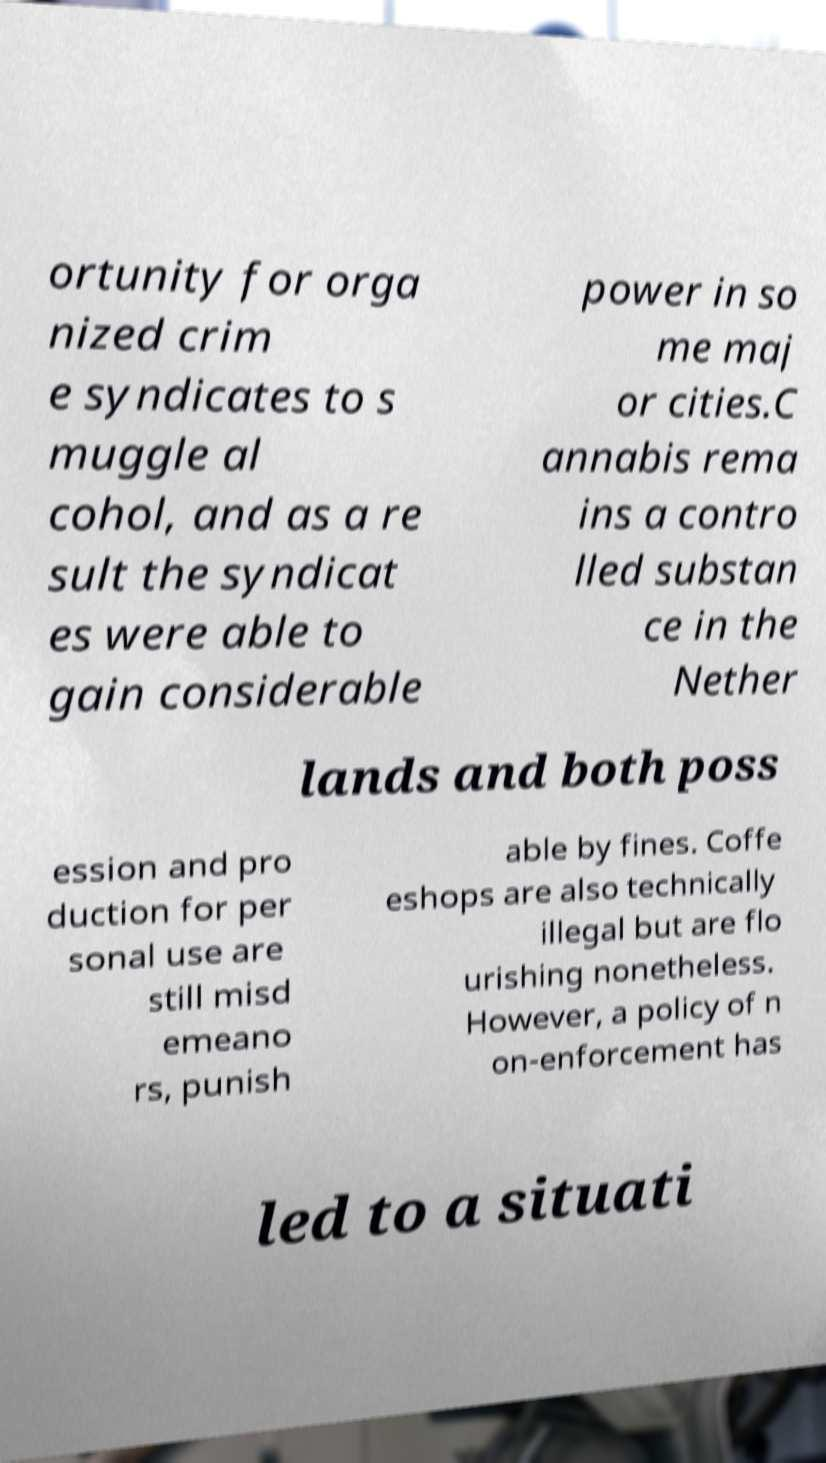For documentation purposes, I need the text within this image transcribed. Could you provide that? ortunity for orga nized crim e syndicates to s muggle al cohol, and as a re sult the syndicat es were able to gain considerable power in so me maj or cities.C annabis rema ins a contro lled substan ce in the Nether lands and both poss ession and pro duction for per sonal use are still misd emeano rs, punish able by fines. Coffe eshops are also technically illegal but are flo urishing nonetheless. However, a policy of n on-enforcement has led to a situati 